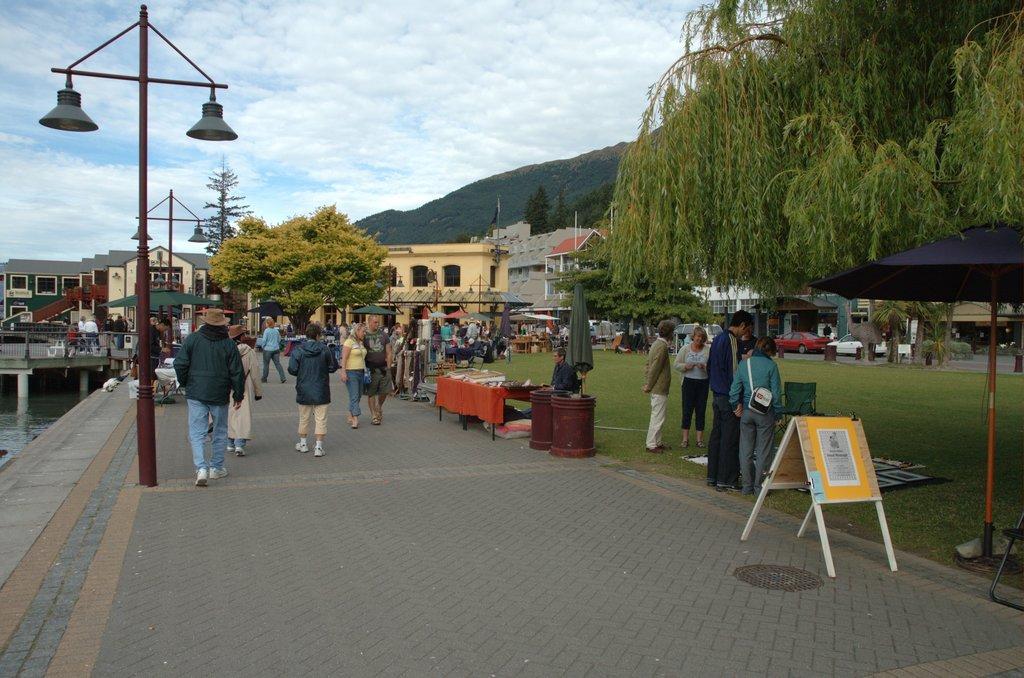Please provide a concise description of this image. In this image there are group of people, stalls, umbrellas with poles, lights, flag , houses, board, trees, grass, bridge, water , hills, and in the background there is sky. 